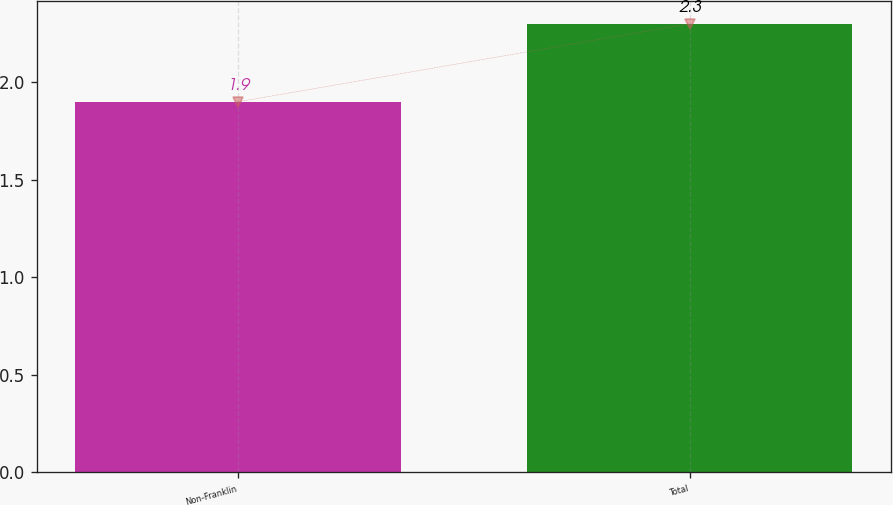<chart> <loc_0><loc_0><loc_500><loc_500><bar_chart><fcel>Non-Franklin<fcel>Total<nl><fcel>1.9<fcel>2.3<nl></chart> 